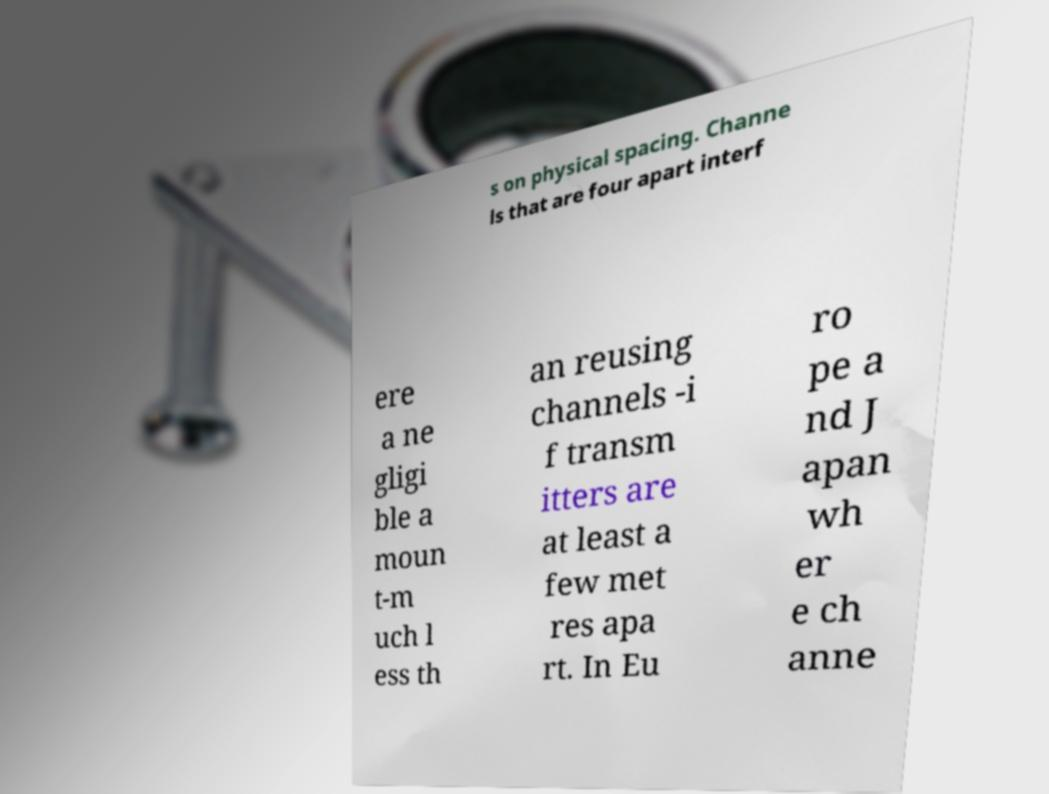There's text embedded in this image that I need extracted. Can you transcribe it verbatim? s on physical spacing. Channe ls that are four apart interf ere a ne gligi ble a moun t-m uch l ess th an reusing channels -i f transm itters are at least a few met res apa rt. In Eu ro pe a nd J apan wh er e ch anne 